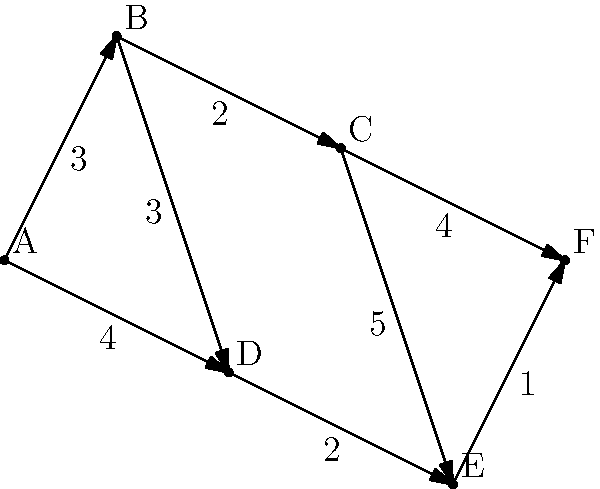Given the graph representing support service locations (nodes) and the travel times between them (edge weights), what is the shortest path from location A to location F, and what is the total travel time? To solve this problem, we'll use Dijkstra's algorithm to find the shortest path from A to F:

1. Initialize:
   - Set distance to A as 0, all others as infinity
   - Set all nodes as unvisited

2. For the current node (starting with A), consider all unvisited neighbors and calculate their tentative distances:
   - A to B: 3
   - A to D: 4

3. Mark A as visited. B has the smallest tentative distance (3), so it becomes the current node.

4. From B:
   - B to C: 3 + 2 = 5
   - B to D: 3 + 3 = 6 (longer than direct A to D, so ignore)

5. Mark B as visited. C has the smallest tentative distance (5), so it becomes the current node.

6. From C:
   - C to E: 5 + 5 = 10
   - C to F: 5 + 4 = 9

7. Mark C as visited. D has the smallest tentative distance (4), so it becomes the current node.

8. From D:
   - D to E: 4 + 2 = 6 (shorter than previous path to E)

9. Mark D as visited. E has the smallest tentative distance (6), so it becomes the current node.

10. From E:
    - E to F: 6 + 1 = 7 (shorter than previous path to F)

11. Mark E as visited. F is the only unvisited node left, so the algorithm terminates.

The shortest path is A -> D -> E -> F, with a total travel time of 7 units.
Answer: A -> D -> E -> F, 7 units 